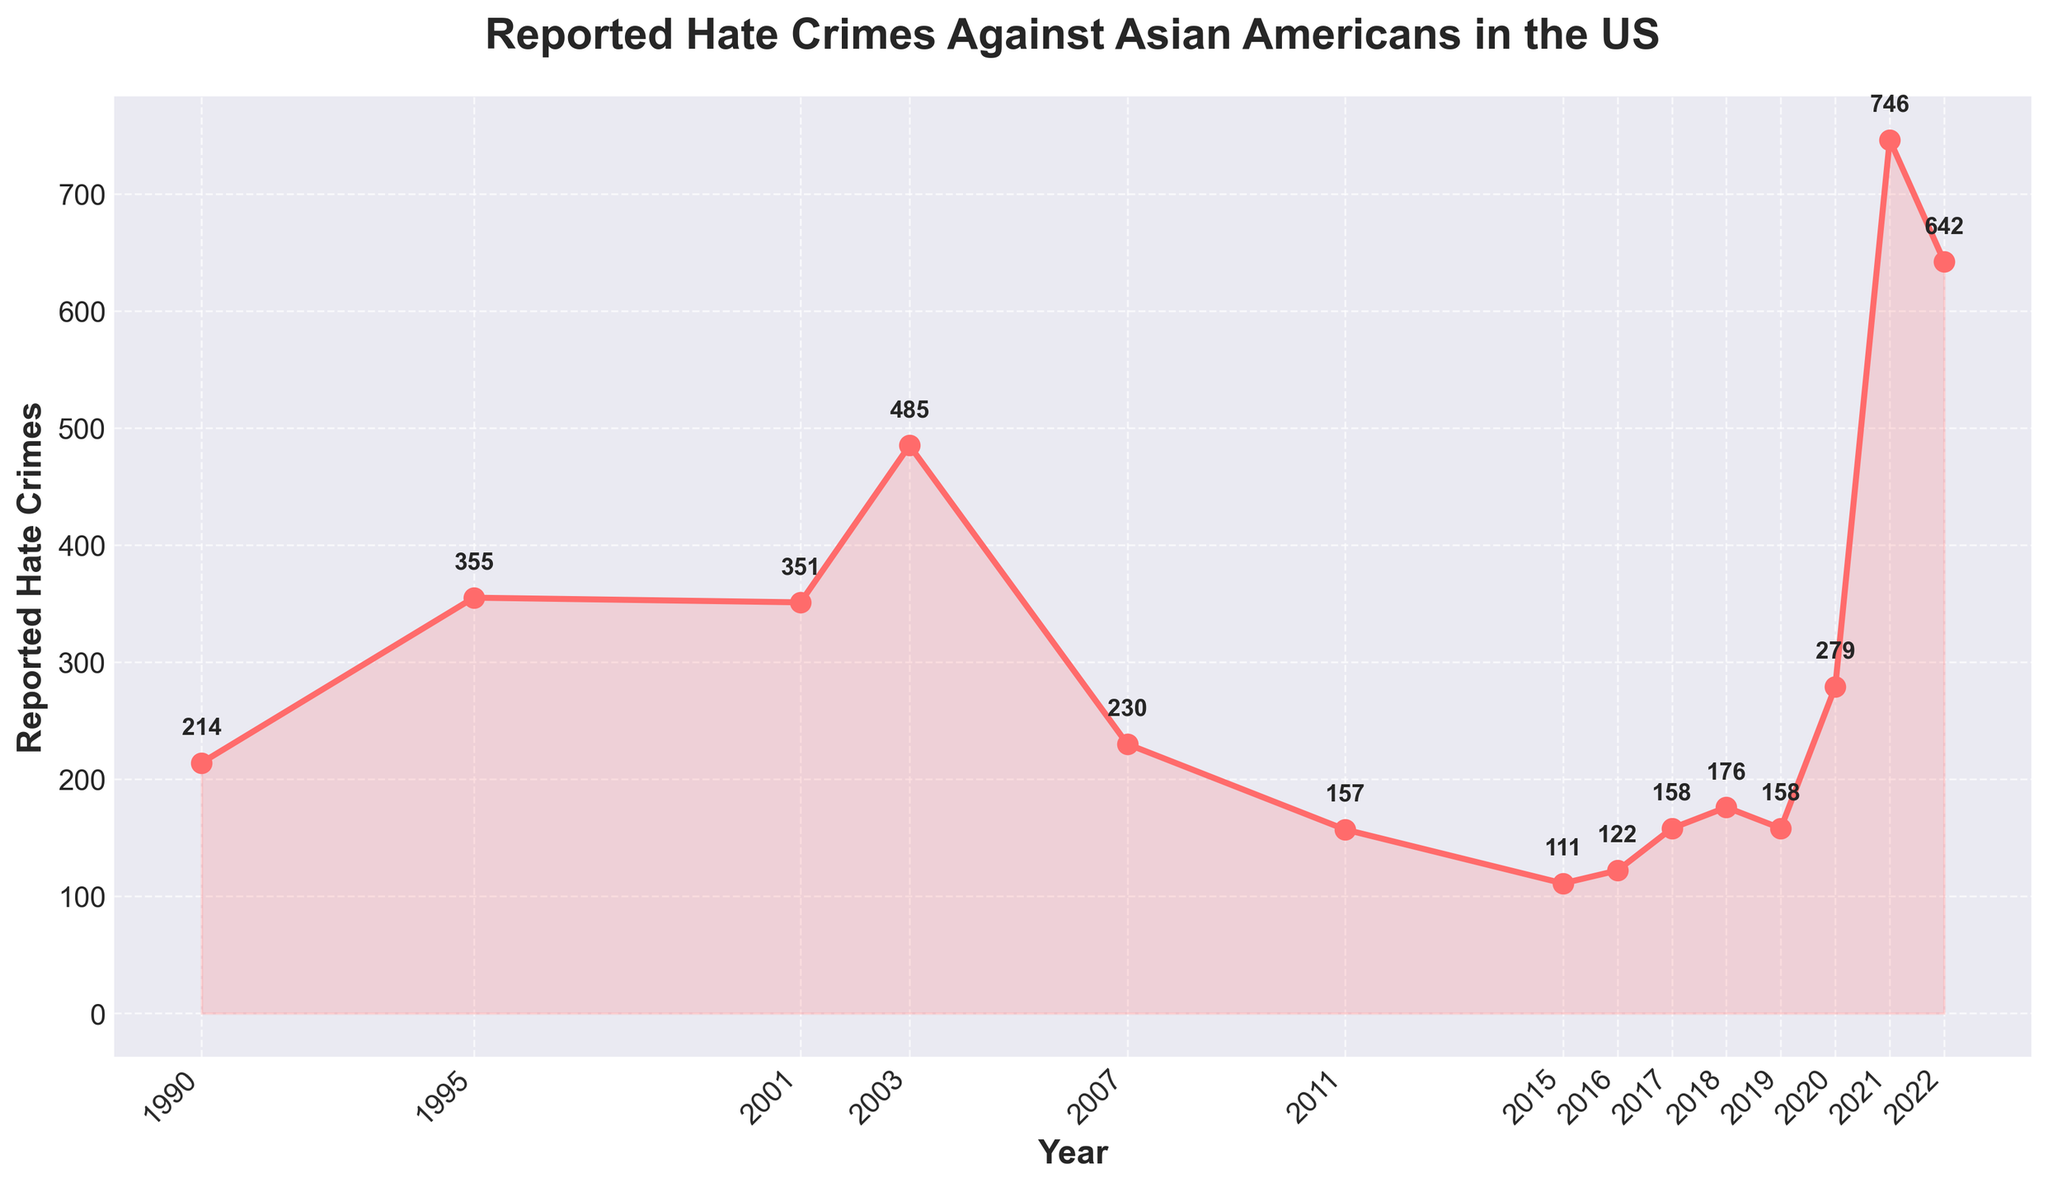What year had the highest number of reported hate crimes against Asian Americans? The highest number on the graph corresponds to 2021, with the datapoint reaching 746.
Answer: 2021 What was the number of reported hate crimes in 2001, and how does it compare to the number in 2003? In 2001, there were 351 reported incidents, whereas in 2003, there were 485. This indicates an increase.
Answer: 2003 had more reported incidents By how much did the number of reported hate crimes change from 1990 to 1995? In 1990, there were 214 reported incidents, and in 1995, there were 355. Subtracting these gives an increase of 141.
Answer: Increased by 141 Which years saw a decrease in the number of reported hate crimes compared to their preceding years? Examining the data points, a decrease is observed from 2003 to 2007, 2007 to 2011, and 2021 to 2022.
Answer: 2003 to 2007, 2007 to 2011, 2021 to 2022 What is the trend in the number of reported hate crimes between 2015 and 2019? The data points from 2015 (111), 2016 (122), 2017 (158), 2018 (176), to 2019 (158) show a general increase, peaking in 2018, followed by a slight decrease in 2019.
Answer: Increasing then slightly decreasing What is the visual indication for the years with significant spikes in the number of reported hate crimes? Significant spikes are visually indicated by the higher peaks in the line plot, notably in 2003 and 2021, where the markers and the line reach higher points compared to adjacent years.
Answer: Higher peaks in 2003 and 2021 Compare the number of reported hate crimes in 1995 and 2016. Was there an increase or decrease and by how much? In 1995, there were 355 incidents and in 2016, there were 122. This results in a decrease of 233.
Answer: Decrease by 233 Calculate the average number of reported hate crimes for the years from 1990 to 2022. Adding the numbers for all the years and dividing by the total number of years (14) gives the average. (214 + 355 + 351 + 485 + 230 + 157 + 111 + 122 + 158 + 176 + 158 + 279 + 746 + 642) / 14 = 2863 / 14 ≈ 204.5
Answer: 204.5 What pattern can be observed in the number of reported hate crimes during periods of international tension such as 2001 and 2020-2021? During periods of international tension, there are notable spikes, as shown by increases in 2001 (351) and significant increases again in 2020 (279) and 2021 (746). This suggests higher reporting in those periods.
Answer: Increased reportage 